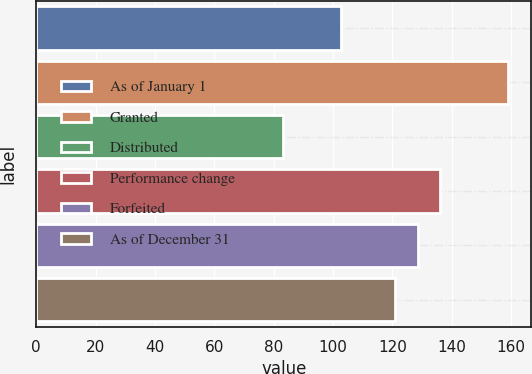Convert chart. <chart><loc_0><loc_0><loc_500><loc_500><bar_chart><fcel>As of January 1<fcel>Granted<fcel>Distributed<fcel>Performance change<fcel>Forfeited<fcel>As of December 31<nl><fcel>102.65<fcel>158.88<fcel>83.08<fcel>136.05<fcel>128.47<fcel>120.89<nl></chart> 